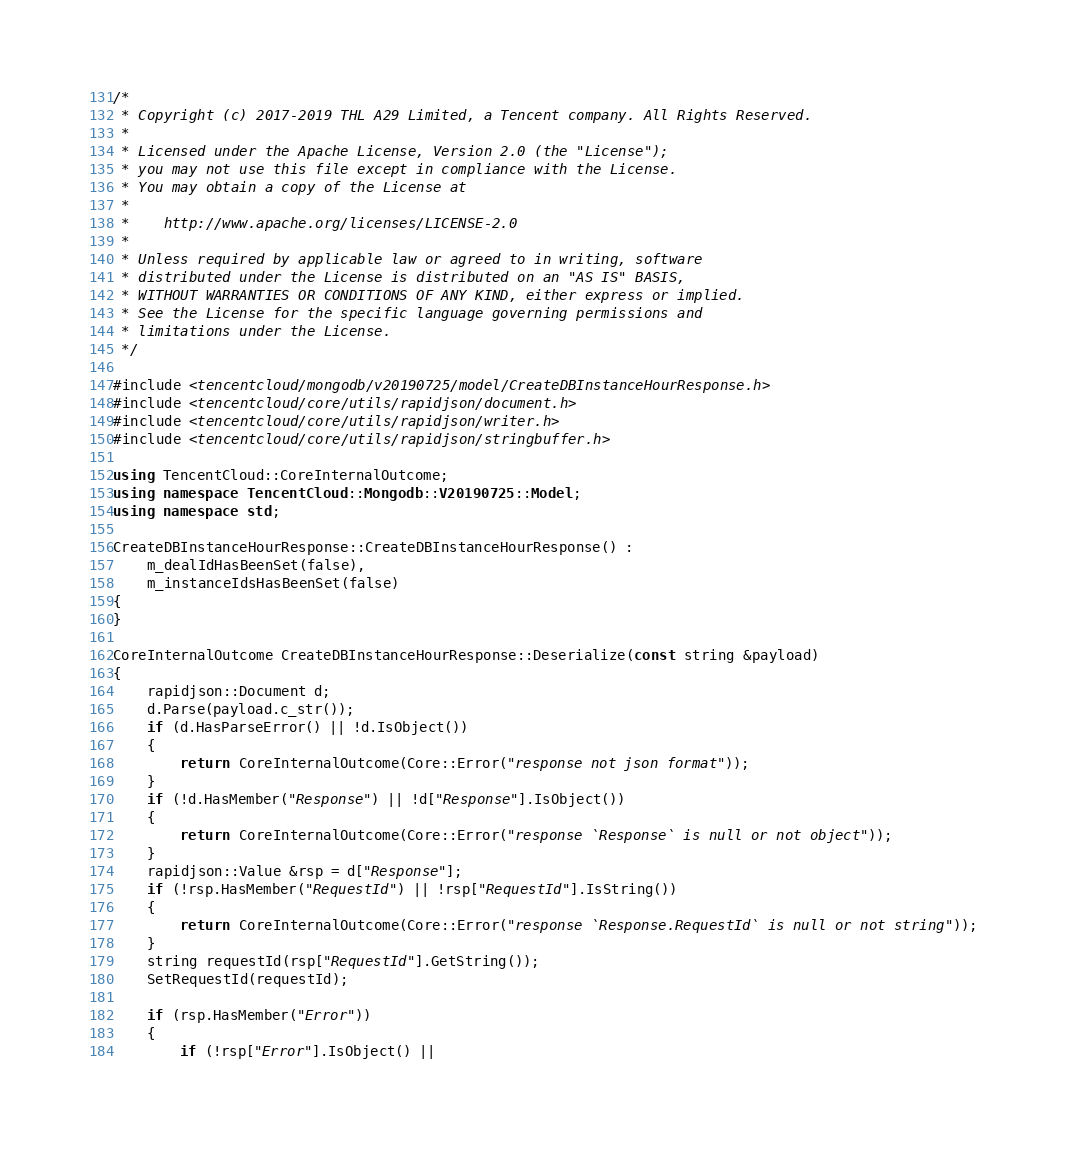<code> <loc_0><loc_0><loc_500><loc_500><_C++_>/*
 * Copyright (c) 2017-2019 THL A29 Limited, a Tencent company. All Rights Reserved.
 *
 * Licensed under the Apache License, Version 2.0 (the "License");
 * you may not use this file except in compliance with the License.
 * You may obtain a copy of the License at
 *
 *    http://www.apache.org/licenses/LICENSE-2.0
 *
 * Unless required by applicable law or agreed to in writing, software
 * distributed under the License is distributed on an "AS IS" BASIS,
 * WITHOUT WARRANTIES OR CONDITIONS OF ANY KIND, either express or implied.
 * See the License for the specific language governing permissions and
 * limitations under the License.
 */

#include <tencentcloud/mongodb/v20190725/model/CreateDBInstanceHourResponse.h>
#include <tencentcloud/core/utils/rapidjson/document.h>
#include <tencentcloud/core/utils/rapidjson/writer.h>
#include <tencentcloud/core/utils/rapidjson/stringbuffer.h>

using TencentCloud::CoreInternalOutcome;
using namespace TencentCloud::Mongodb::V20190725::Model;
using namespace std;

CreateDBInstanceHourResponse::CreateDBInstanceHourResponse() :
    m_dealIdHasBeenSet(false),
    m_instanceIdsHasBeenSet(false)
{
}

CoreInternalOutcome CreateDBInstanceHourResponse::Deserialize(const string &payload)
{
    rapidjson::Document d;
    d.Parse(payload.c_str());
    if (d.HasParseError() || !d.IsObject())
    {
        return CoreInternalOutcome(Core::Error("response not json format"));
    }
    if (!d.HasMember("Response") || !d["Response"].IsObject())
    {
        return CoreInternalOutcome(Core::Error("response `Response` is null or not object"));
    }
    rapidjson::Value &rsp = d["Response"];
    if (!rsp.HasMember("RequestId") || !rsp["RequestId"].IsString())
    {
        return CoreInternalOutcome(Core::Error("response `Response.RequestId` is null or not string"));
    }
    string requestId(rsp["RequestId"].GetString());
    SetRequestId(requestId);

    if (rsp.HasMember("Error"))
    {
        if (!rsp["Error"].IsObject() ||</code> 